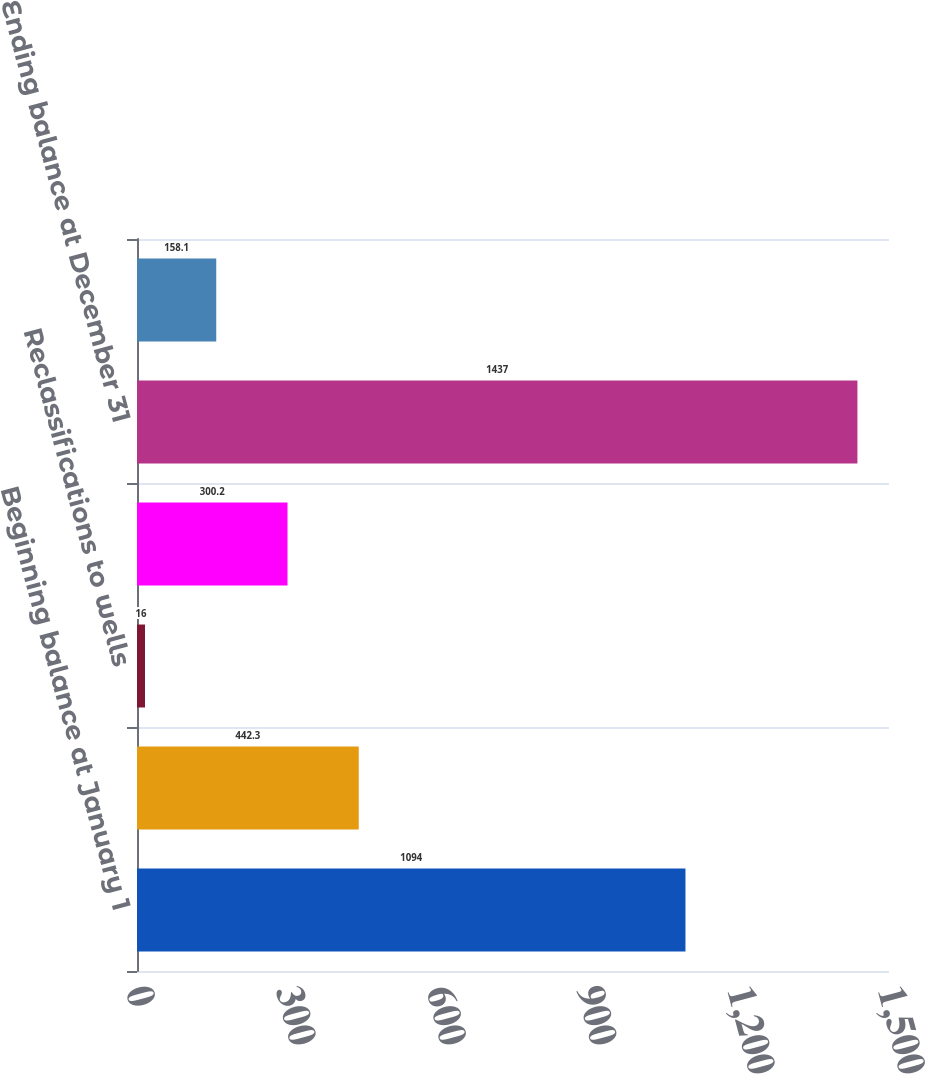<chart> <loc_0><loc_0><loc_500><loc_500><bar_chart><fcel>Beginning balance at January 1<fcel>Additions to capitalized<fcel>Reclassifications to wells<fcel>Capitalized exploratory well<fcel>Ending balance at December 31<fcel>Number of wells at end of year<nl><fcel>1094<fcel>442.3<fcel>16<fcel>300.2<fcel>1437<fcel>158.1<nl></chart> 